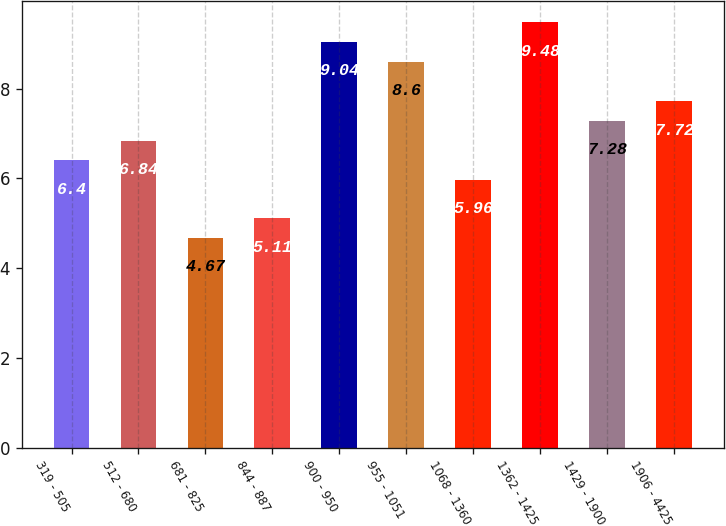Convert chart. <chart><loc_0><loc_0><loc_500><loc_500><bar_chart><fcel>319 - 505<fcel>512 - 680<fcel>681 - 825<fcel>844 - 887<fcel>900 - 950<fcel>955 - 1051<fcel>1068 - 1360<fcel>1362 - 1425<fcel>1429 - 1900<fcel>1906 - 4425<nl><fcel>6.4<fcel>6.84<fcel>4.67<fcel>5.11<fcel>9.04<fcel>8.6<fcel>5.96<fcel>9.48<fcel>7.28<fcel>7.72<nl></chart> 